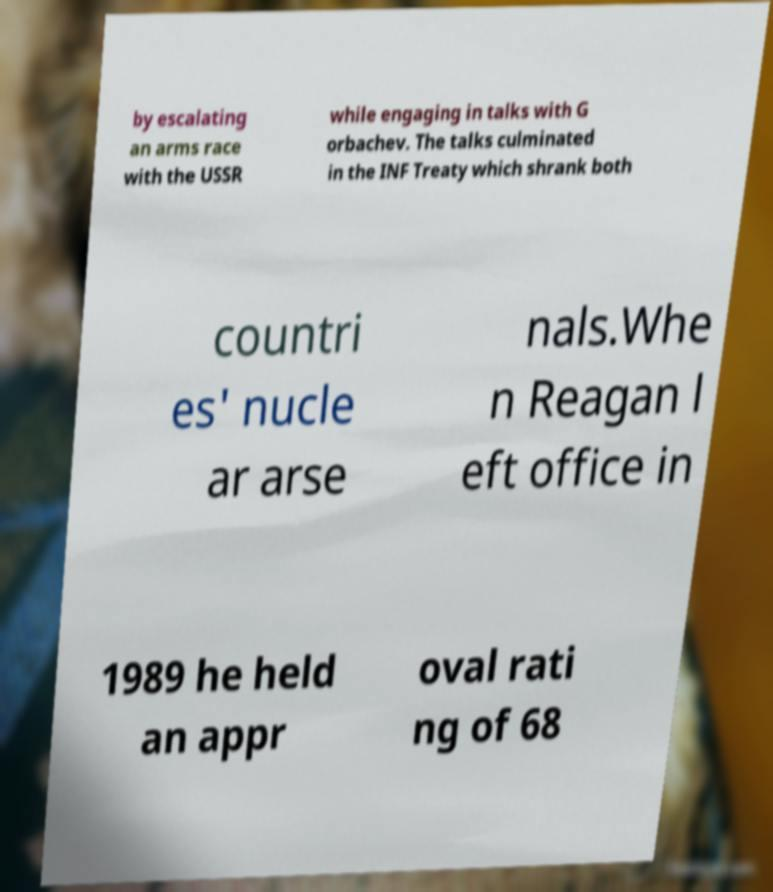Could you extract and type out the text from this image? by escalating an arms race with the USSR while engaging in talks with G orbachev. The talks culminated in the INF Treaty which shrank both countri es' nucle ar arse nals.Whe n Reagan l eft office in 1989 he held an appr oval rati ng of 68 